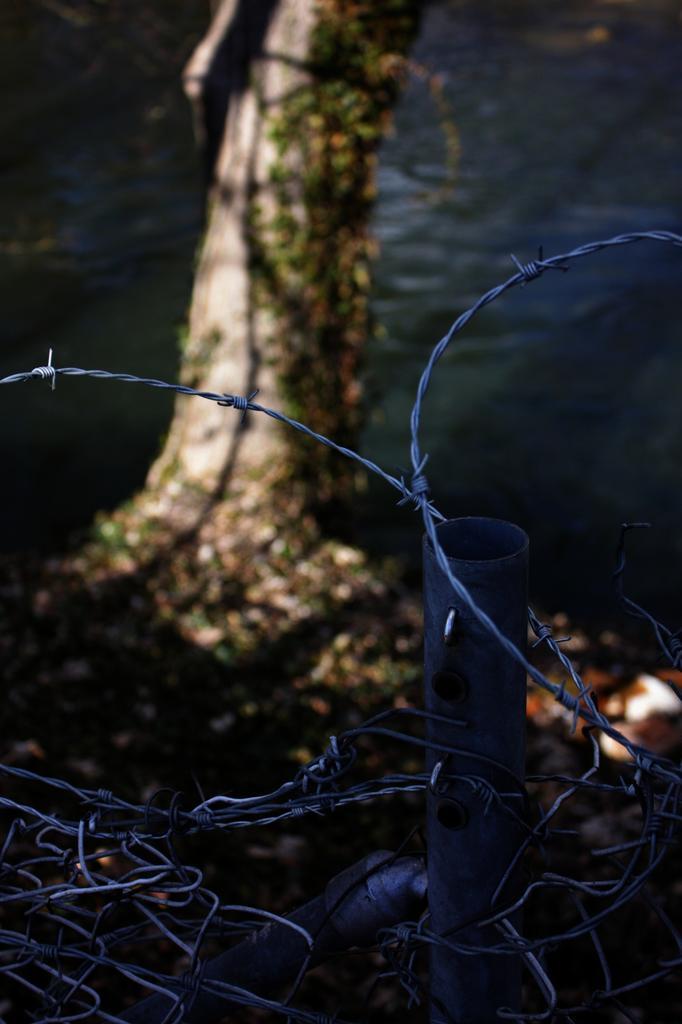In one or two sentences, can you explain what this image depicts? In this picture there is a fence in the foreground. At the back there is a tree. At the bottom there is water. 